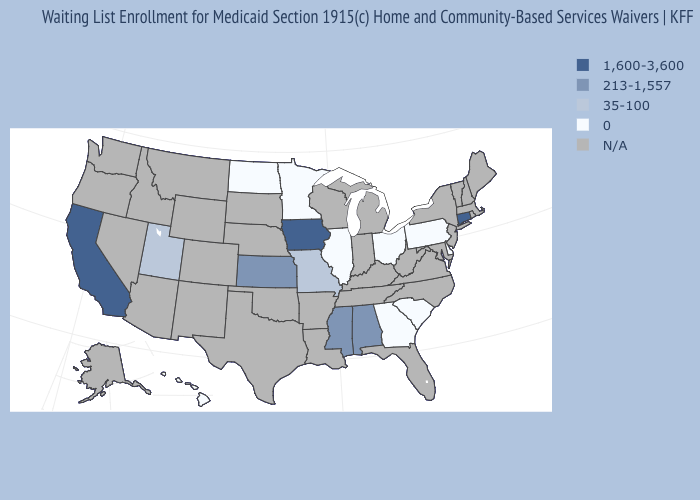What is the value of New York?
Concise answer only. N/A. What is the value of Alaska?
Concise answer only. N/A. What is the lowest value in the USA?
Keep it brief. 0. How many symbols are there in the legend?
Concise answer only. 5. Which states have the highest value in the USA?
Quick response, please. California, Connecticut, Iowa. Name the states that have a value in the range 0?
Answer briefly. Delaware, Georgia, Hawaii, Illinois, Minnesota, North Dakota, Ohio, Pennsylvania, South Carolina. Is the legend a continuous bar?
Answer briefly. No. What is the value of Delaware?
Answer briefly. 0. What is the value of Washington?
Concise answer only. N/A. Which states have the lowest value in the South?
Quick response, please. Delaware, Georgia, South Carolina. What is the value of Massachusetts?
Write a very short answer. N/A. 